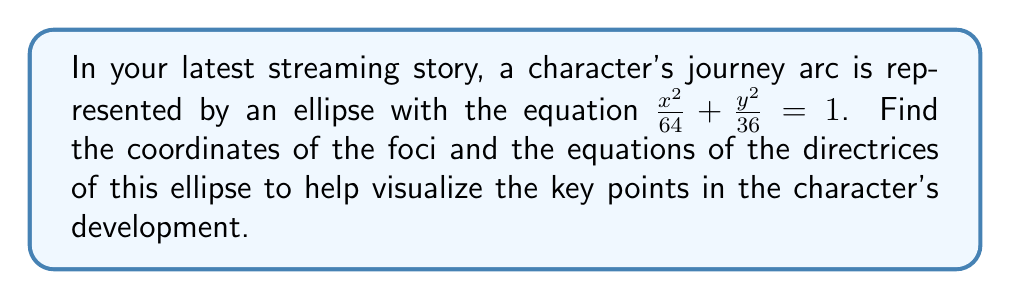Show me your answer to this math problem. To find the foci and directrices of the ellipse, we'll follow these steps:

1) First, identify the semi-major and semi-minor axes:
   $a^2 = 64$, so $a = 8$
   $b^2 = 36$, so $b = 6$

2) The ellipse is centered at the origin (0,0) and the major axis is horizontal because $a^2 > b^2$.

3) Calculate $c$ (the distance from the center to a focus):
   $c^2 = a^2 - b^2 = 64 - 36 = 28$
   $c = \sqrt{28} = 2\sqrt{7}$

4) The foci are located at $(\pm c, 0)$:
   $F_1 = (-2\sqrt{7}, 0)$ and $F_2 = (2\sqrt{7}, 0)$

5) To find the directrices, we use the equation $x = \pm \frac{a^2}{c}$:
   $x = \pm \frac{64}{2\sqrt{7}} = \pm \frac{32}{\sqrt{7}}$

[asy]
import geometry;

size(200);
real a = 8;
real b = 6;
real c = 2*sqrt(7);

draw(ellipse((0,0), a, b));
draw((-a,0)--(a,0), dashed);
draw((0,-b)--(0,b), dashed);

dot((c,0), red);
dot((-c,0), red);
label("$F_1$", (-c,0), SW, red);
label("$F_2$", (c,0), SE, red);

real x = 32/sqrt(7);
draw((-x,-b)--(-x,b), blue);
draw((x,-b)--(x,b), blue);
label("Directrix", (-x,b), N, blue);
label("Directrix", (x,b), N, blue);
[/asy]
Answer: Foci: $F_1 = (-2\sqrt{7}, 0)$ and $F_2 = (2\sqrt{7}, 0)$
Directrices: $x = \pm \frac{32}{\sqrt{7}}$ 